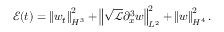Convert formula to latex. <formula><loc_0><loc_0><loc_500><loc_500>\mathcal { E } ( t ) = \left \| w _ { t } \right \| _ { H ^ { 3 } } ^ { 2 } + \left \| \sqrt { \ m a t h s c r { L } } \partial _ { x } ^ { 3 } w \right \| _ { L ^ { 2 } } ^ { 2 } + \left \| w \right \| _ { H ^ { 4 } } ^ { 2 } .</formula> 